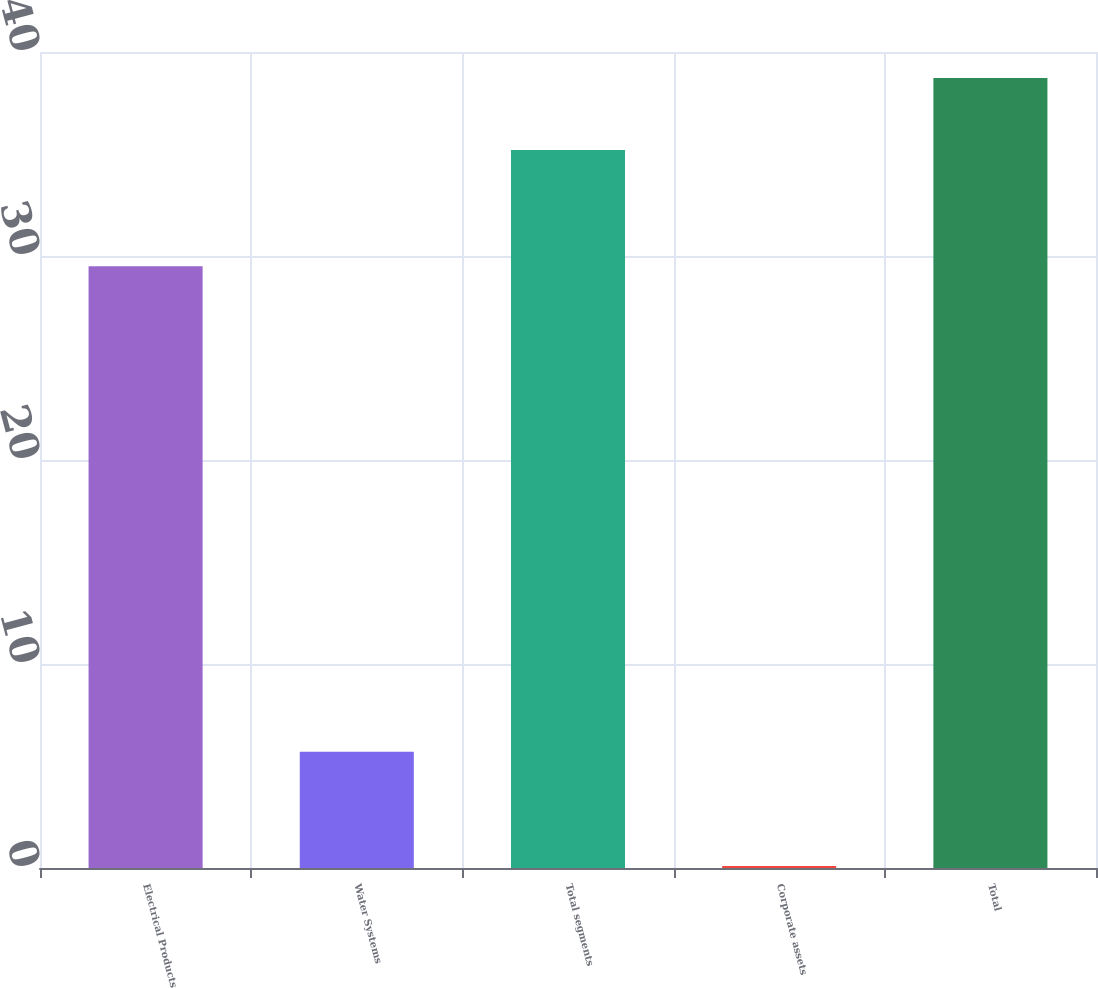<chart> <loc_0><loc_0><loc_500><loc_500><bar_chart><fcel>Electrical Products<fcel>Water Systems<fcel>Total segments<fcel>Corporate assets<fcel>Total<nl><fcel>29.5<fcel>5.7<fcel>35.2<fcel>0.1<fcel>38.72<nl></chart> 